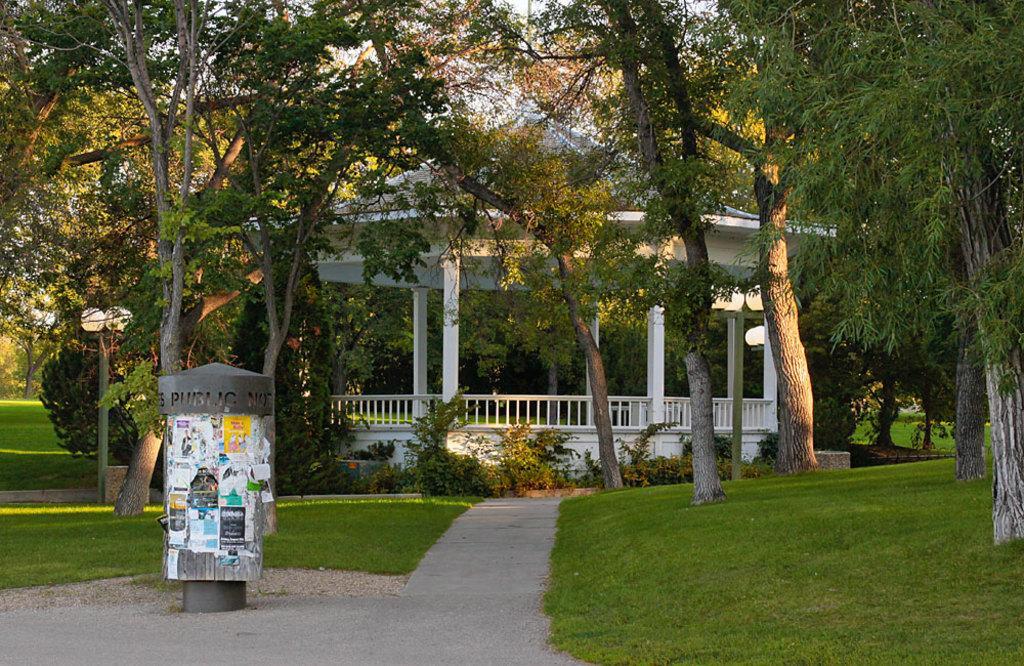Can you describe this image briefly? In this picture I can see papers attached on an object, there are poles, lights, there are plants, grass, there is a gazebo, and in the background there are trees. 